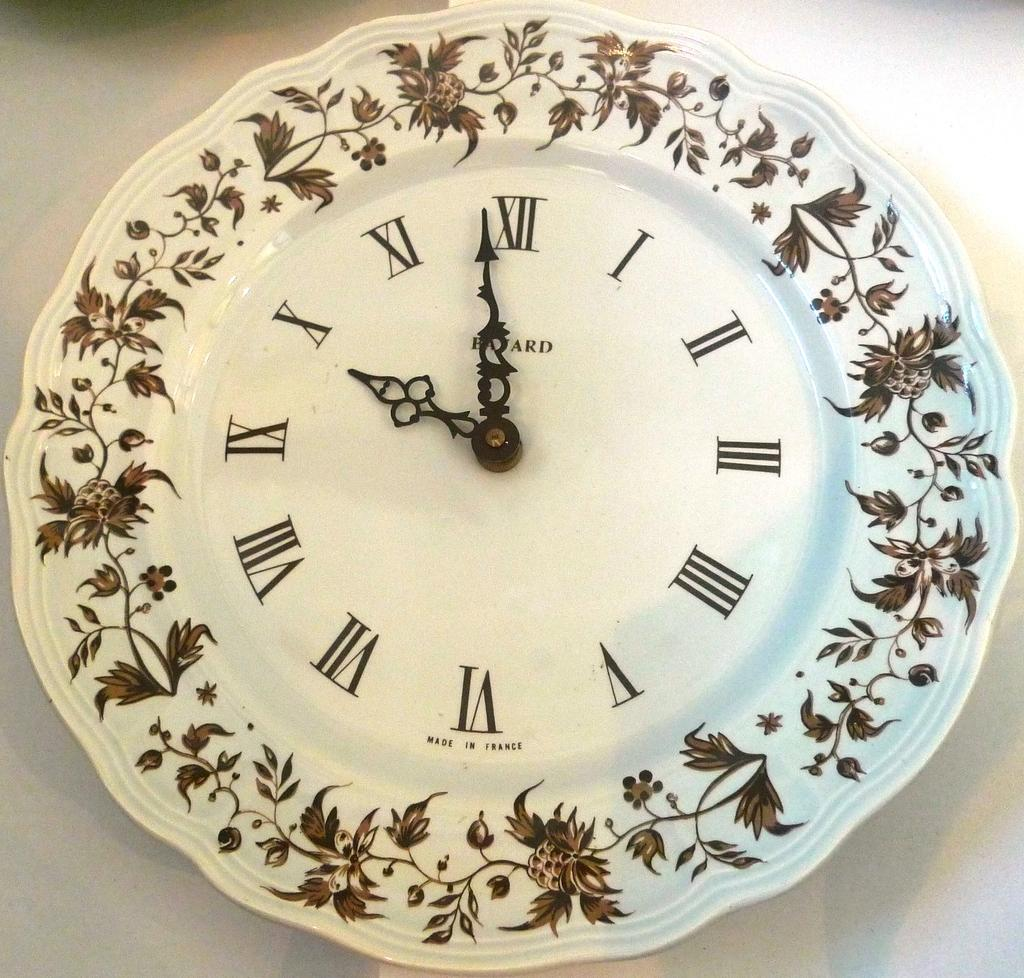Provide a one-sentence caption for the provided image. A clock that is displaying the time of 9:58. 